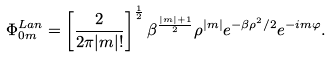<formula> <loc_0><loc_0><loc_500><loc_500>\Phi _ { 0 m } ^ { L a n } = \left [ \frac { 2 } { 2 \pi | m | ! } \right ] ^ { \frac { 1 } { 2 } } \beta ^ { \frac { | m | + 1 } { 2 } } \rho ^ { | m | } e ^ { - \beta \rho ^ { 2 } / 2 } e ^ { - i m \varphi } .</formula> 